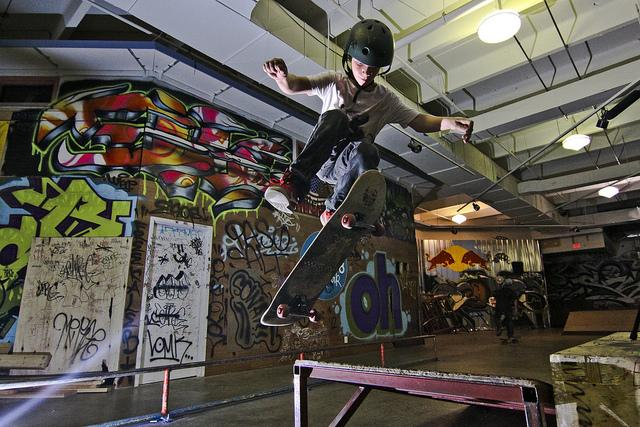How did the skateboarder get so high in the air? Please explain your reasoning. ramp. The skater rode off an elevated platform 